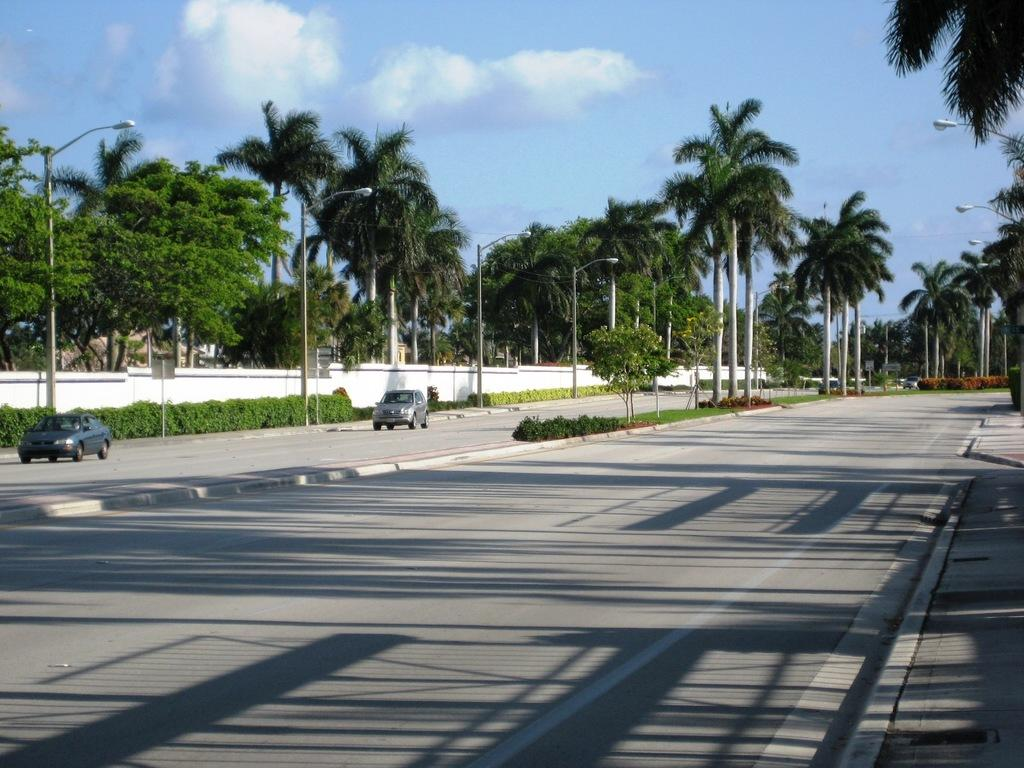Where was the image taken? The image was taken on a road. What can be seen on the left side of the image? There is a car on the left side of the image. What is visible in the background of the image? There are trees and plants in the background of the image. What type of magic is being performed by the pot in the image? There is no pot or magic present in the image. What reward is being given to the person in the image? There is no person or reward visible in the image. 